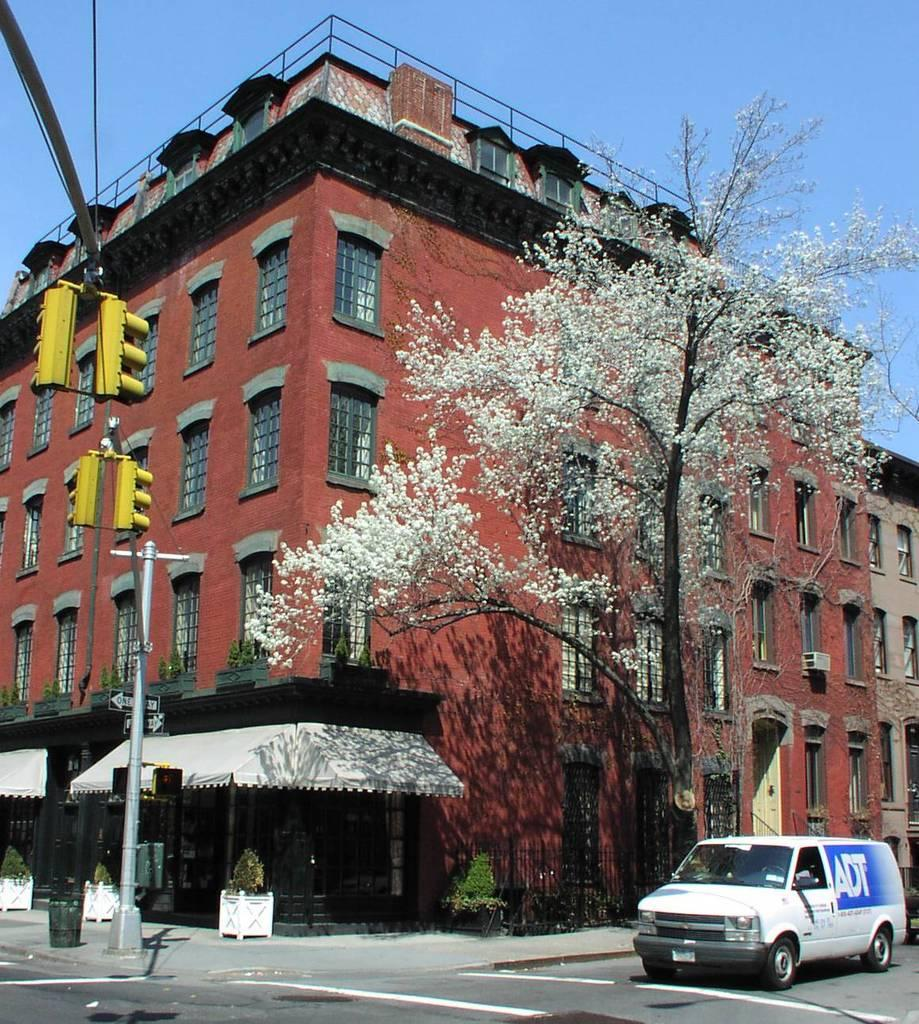What type of structure can be seen in the image? There is a building in the image. What natural elements are present in the image? There are trees and plants in the image. What type of traffic control devices are visible in the image? Signal lights are present in the image. What type of support structures can be seen in the image? Poles are visible in the image. What type of transportation is present in the image? There is a vehicle in the image. What safety feature is present in the image? Railing is present in the image. What part of the natural environment is visible in the image? The sky is visible in the image. What additional objects can be seen in the image? There are objects in the image. What type of memory is stored in the vehicle in the image? There is no information about memory storage in the vehicle in the image. Are there any police officers visible in the image? There is no mention of police officers in the image. What time of day is depicted in the image? The time of day is not mentioned in the image. 